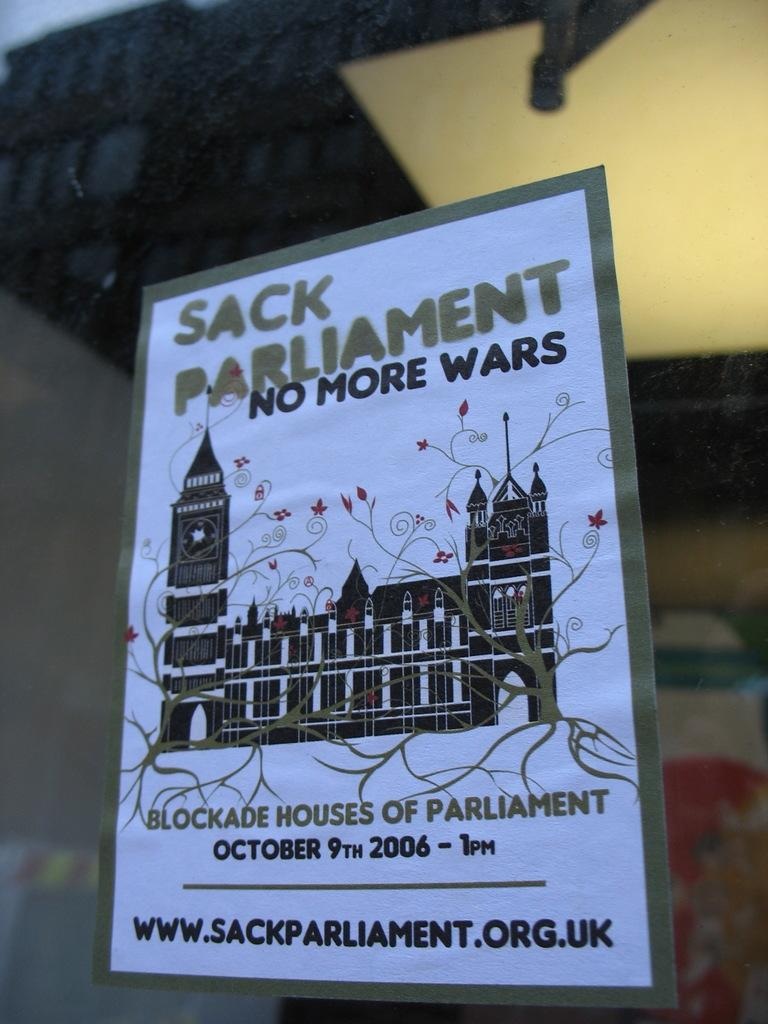<image>
Present a compact description of the photo's key features. a flier for Sack parliment, dated for octiber 9, 2006 has an image of a large building on it 